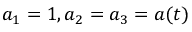<formula> <loc_0><loc_0><loc_500><loc_500>a _ { 1 } = 1 , a _ { 2 } = a _ { 3 } = a ( t )</formula> 